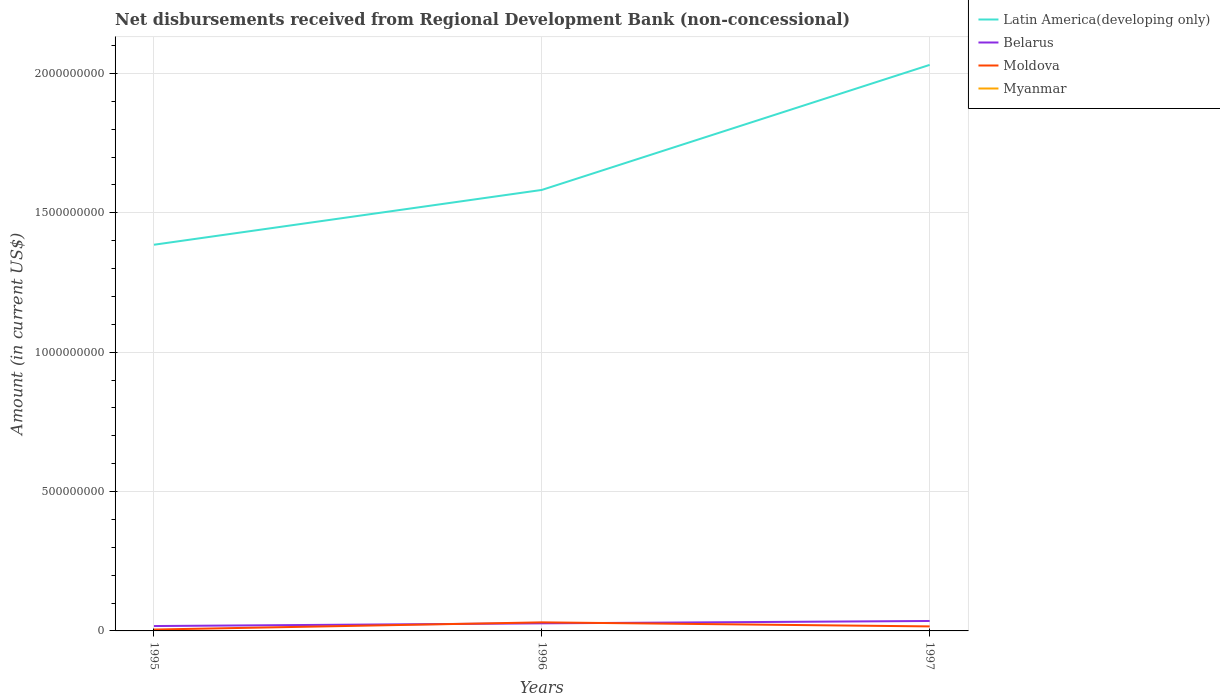Is the number of lines equal to the number of legend labels?
Offer a terse response. No. Across all years, what is the maximum amount of disbursements received from Regional Development Bank in Moldova?
Offer a very short reply. 4.94e+06. What is the total amount of disbursements received from Regional Development Bank in Belarus in the graph?
Offer a terse response. -1.81e+07. What is the difference between the highest and the second highest amount of disbursements received from Regional Development Bank in Belarus?
Offer a very short reply. 1.81e+07. How many years are there in the graph?
Give a very brief answer. 3. What is the difference between two consecutive major ticks on the Y-axis?
Provide a succinct answer. 5.00e+08. Are the values on the major ticks of Y-axis written in scientific E-notation?
Offer a terse response. No. Where does the legend appear in the graph?
Your answer should be very brief. Top right. How are the legend labels stacked?
Your response must be concise. Vertical. What is the title of the graph?
Your answer should be very brief. Net disbursements received from Regional Development Bank (non-concessional). What is the label or title of the X-axis?
Offer a very short reply. Years. What is the label or title of the Y-axis?
Make the answer very short. Amount (in current US$). What is the Amount (in current US$) in Latin America(developing only) in 1995?
Provide a succinct answer. 1.39e+09. What is the Amount (in current US$) of Belarus in 1995?
Make the answer very short. 1.75e+07. What is the Amount (in current US$) in Moldova in 1995?
Keep it short and to the point. 4.94e+06. What is the Amount (in current US$) of Latin America(developing only) in 1996?
Ensure brevity in your answer.  1.58e+09. What is the Amount (in current US$) in Belarus in 1996?
Offer a terse response. 2.72e+07. What is the Amount (in current US$) of Moldova in 1996?
Keep it short and to the point. 3.07e+07. What is the Amount (in current US$) of Latin America(developing only) in 1997?
Give a very brief answer. 2.03e+09. What is the Amount (in current US$) in Belarus in 1997?
Make the answer very short. 3.56e+07. What is the Amount (in current US$) of Moldova in 1997?
Offer a very short reply. 1.62e+07. What is the Amount (in current US$) in Myanmar in 1997?
Provide a succinct answer. 0. Across all years, what is the maximum Amount (in current US$) in Latin America(developing only)?
Give a very brief answer. 2.03e+09. Across all years, what is the maximum Amount (in current US$) of Belarus?
Provide a short and direct response. 3.56e+07. Across all years, what is the maximum Amount (in current US$) in Moldova?
Your answer should be very brief. 3.07e+07. Across all years, what is the minimum Amount (in current US$) of Latin America(developing only)?
Make the answer very short. 1.39e+09. Across all years, what is the minimum Amount (in current US$) in Belarus?
Keep it short and to the point. 1.75e+07. Across all years, what is the minimum Amount (in current US$) in Moldova?
Provide a short and direct response. 4.94e+06. What is the total Amount (in current US$) in Latin America(developing only) in the graph?
Your answer should be very brief. 5.00e+09. What is the total Amount (in current US$) in Belarus in the graph?
Make the answer very short. 8.04e+07. What is the total Amount (in current US$) in Moldova in the graph?
Your response must be concise. 5.18e+07. What is the difference between the Amount (in current US$) of Latin America(developing only) in 1995 and that in 1996?
Your answer should be very brief. -1.97e+08. What is the difference between the Amount (in current US$) of Belarus in 1995 and that in 1996?
Your answer should be very brief. -9.69e+06. What is the difference between the Amount (in current US$) in Moldova in 1995 and that in 1996?
Offer a terse response. -2.58e+07. What is the difference between the Amount (in current US$) of Latin America(developing only) in 1995 and that in 1997?
Offer a terse response. -6.45e+08. What is the difference between the Amount (in current US$) of Belarus in 1995 and that in 1997?
Your answer should be compact. -1.81e+07. What is the difference between the Amount (in current US$) in Moldova in 1995 and that in 1997?
Offer a very short reply. -1.12e+07. What is the difference between the Amount (in current US$) of Latin America(developing only) in 1996 and that in 1997?
Provide a succinct answer. -4.49e+08. What is the difference between the Amount (in current US$) in Belarus in 1996 and that in 1997?
Provide a short and direct response. -8.45e+06. What is the difference between the Amount (in current US$) in Moldova in 1996 and that in 1997?
Provide a succinct answer. 1.45e+07. What is the difference between the Amount (in current US$) in Latin America(developing only) in 1995 and the Amount (in current US$) in Belarus in 1996?
Give a very brief answer. 1.36e+09. What is the difference between the Amount (in current US$) of Latin America(developing only) in 1995 and the Amount (in current US$) of Moldova in 1996?
Make the answer very short. 1.35e+09. What is the difference between the Amount (in current US$) in Belarus in 1995 and the Amount (in current US$) in Moldova in 1996?
Provide a succinct answer. -1.32e+07. What is the difference between the Amount (in current US$) in Latin America(developing only) in 1995 and the Amount (in current US$) in Belarus in 1997?
Keep it short and to the point. 1.35e+09. What is the difference between the Amount (in current US$) of Latin America(developing only) in 1995 and the Amount (in current US$) of Moldova in 1997?
Provide a short and direct response. 1.37e+09. What is the difference between the Amount (in current US$) of Belarus in 1995 and the Amount (in current US$) of Moldova in 1997?
Your response must be concise. 1.34e+06. What is the difference between the Amount (in current US$) in Latin America(developing only) in 1996 and the Amount (in current US$) in Belarus in 1997?
Make the answer very short. 1.55e+09. What is the difference between the Amount (in current US$) in Latin America(developing only) in 1996 and the Amount (in current US$) in Moldova in 1997?
Give a very brief answer. 1.57e+09. What is the difference between the Amount (in current US$) in Belarus in 1996 and the Amount (in current US$) in Moldova in 1997?
Offer a very short reply. 1.10e+07. What is the average Amount (in current US$) in Latin America(developing only) per year?
Provide a short and direct response. 1.67e+09. What is the average Amount (in current US$) of Belarus per year?
Provide a short and direct response. 2.68e+07. What is the average Amount (in current US$) in Moldova per year?
Your response must be concise. 1.73e+07. What is the average Amount (in current US$) of Myanmar per year?
Offer a very short reply. 0. In the year 1995, what is the difference between the Amount (in current US$) of Latin America(developing only) and Amount (in current US$) of Belarus?
Your answer should be very brief. 1.37e+09. In the year 1995, what is the difference between the Amount (in current US$) in Latin America(developing only) and Amount (in current US$) in Moldova?
Offer a terse response. 1.38e+09. In the year 1995, what is the difference between the Amount (in current US$) of Belarus and Amount (in current US$) of Moldova?
Make the answer very short. 1.26e+07. In the year 1996, what is the difference between the Amount (in current US$) of Latin America(developing only) and Amount (in current US$) of Belarus?
Your response must be concise. 1.56e+09. In the year 1996, what is the difference between the Amount (in current US$) in Latin America(developing only) and Amount (in current US$) in Moldova?
Give a very brief answer. 1.55e+09. In the year 1996, what is the difference between the Amount (in current US$) of Belarus and Amount (in current US$) of Moldova?
Keep it short and to the point. -3.50e+06. In the year 1997, what is the difference between the Amount (in current US$) of Latin America(developing only) and Amount (in current US$) of Belarus?
Your response must be concise. 2.00e+09. In the year 1997, what is the difference between the Amount (in current US$) of Latin America(developing only) and Amount (in current US$) of Moldova?
Keep it short and to the point. 2.01e+09. In the year 1997, what is the difference between the Amount (in current US$) in Belarus and Amount (in current US$) in Moldova?
Provide a succinct answer. 1.95e+07. What is the ratio of the Amount (in current US$) in Latin America(developing only) in 1995 to that in 1996?
Give a very brief answer. 0.88. What is the ratio of the Amount (in current US$) of Belarus in 1995 to that in 1996?
Offer a terse response. 0.64. What is the ratio of the Amount (in current US$) in Moldova in 1995 to that in 1996?
Provide a succinct answer. 0.16. What is the ratio of the Amount (in current US$) of Latin America(developing only) in 1995 to that in 1997?
Your answer should be compact. 0.68. What is the ratio of the Amount (in current US$) in Belarus in 1995 to that in 1997?
Give a very brief answer. 0.49. What is the ratio of the Amount (in current US$) of Moldova in 1995 to that in 1997?
Provide a succinct answer. 0.31. What is the ratio of the Amount (in current US$) of Latin America(developing only) in 1996 to that in 1997?
Make the answer very short. 0.78. What is the ratio of the Amount (in current US$) of Belarus in 1996 to that in 1997?
Your answer should be compact. 0.76. What is the ratio of the Amount (in current US$) of Moldova in 1996 to that in 1997?
Make the answer very short. 1.9. What is the difference between the highest and the second highest Amount (in current US$) of Latin America(developing only)?
Your answer should be very brief. 4.49e+08. What is the difference between the highest and the second highest Amount (in current US$) in Belarus?
Keep it short and to the point. 8.45e+06. What is the difference between the highest and the second highest Amount (in current US$) in Moldova?
Provide a short and direct response. 1.45e+07. What is the difference between the highest and the lowest Amount (in current US$) of Latin America(developing only)?
Give a very brief answer. 6.45e+08. What is the difference between the highest and the lowest Amount (in current US$) of Belarus?
Give a very brief answer. 1.81e+07. What is the difference between the highest and the lowest Amount (in current US$) of Moldova?
Your response must be concise. 2.58e+07. 